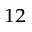Convert formula to latex. <formula><loc_0><loc_0><loc_500><loc_500>^ { 1 2 }</formula> 